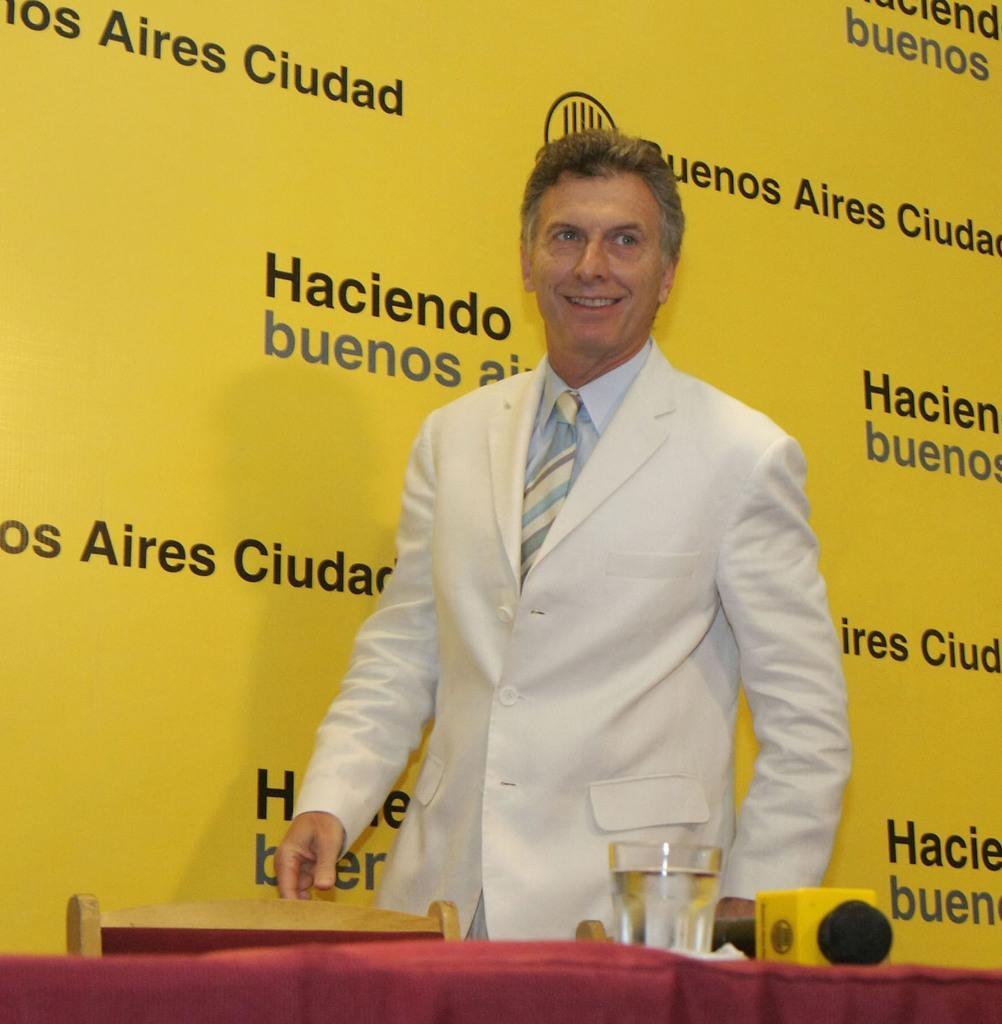Can you describe this image briefly? In this picture I can see a man standing and smiling, there is a chair, there is a glass of water, mike and a tissue on the table, and in the background there is a board. 